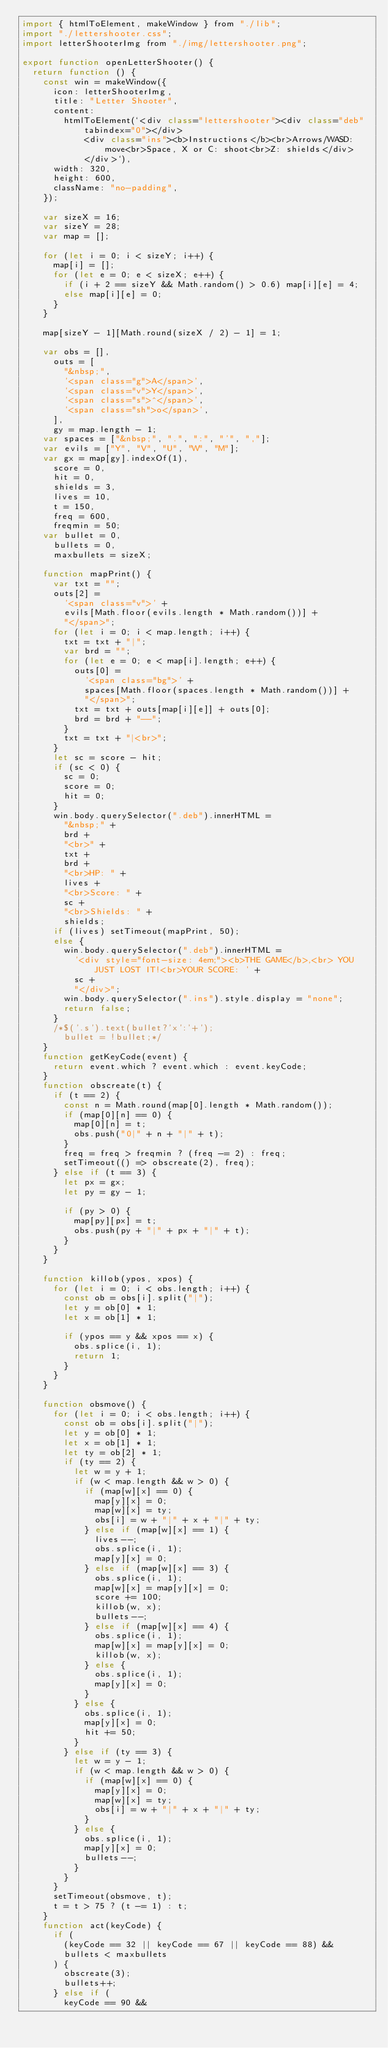<code> <loc_0><loc_0><loc_500><loc_500><_JavaScript_>import { htmlToElement, makeWindow } from "./lib";
import "./lettershooter.css";
import letterShooterImg from "./img/lettershooter.png";

export function openLetterShooter() {
  return function () {
    const win = makeWindow({
      icon: letterShooterImg,
      title: "Letter Shooter",
      content:
        htmlToElement(`<div class="lettershooter"><div class="deb" tabindex="0"></div>
            <div class="ins"><b>Instructions</b><br>Arrows/WASD: move<br>Space, X or C: shoot<br>Z: shields</div>
            </div>`),
      width: 320,
      height: 600,
      className: "no-padding",
    });

    var sizeX = 16;
    var sizeY = 28;
    var map = [];

    for (let i = 0; i < sizeY; i++) {
      map[i] = [];
      for (let e = 0; e < sizeX; e++) {
        if (i + 2 == sizeY && Math.random() > 0.6) map[i][e] = 4;
        else map[i][e] = 0;
      }
    }

    map[sizeY - 1][Math.round(sizeX / 2) - 1] = 1;

    var obs = [],
      outs = [
        "&nbsp;",
        '<span class="g">A</span>',
        '<span class="v">Y</span>',
        '<span class="s">^</span>',
        '<span class="sh">o</span>',
      ],
      gy = map.length - 1;
    var spaces = ["&nbsp;", ".", ":", "'", ","];
    var evils = ["Y", "V", "U", "W", "M"];
    var gx = map[gy].indexOf(1),
      score = 0,
      hit = 0,
      shields = 3,
      lives = 10,
      t = 150,
      freq = 600,
      freqmin = 50;
    var bullet = 0,
      bullets = 0,
      maxbullets = sizeX;

    function mapPrint() {
      var txt = "";
      outs[2] =
        '<span class="v">' +
        evils[Math.floor(evils.length * Math.random())] +
        "</span>";
      for (let i = 0; i < map.length; i++) {
        txt = txt + "|";
        var brd = "";
        for (let e = 0; e < map[i].length; e++) {
          outs[0] =
            '<span class="bg">' +
            spaces[Math.floor(spaces.length * Math.random())] +
            "</span>";
          txt = txt + outs[map[i][e]] + outs[0];
          brd = brd + "--";
        }
        txt = txt + "|<br>";
      }
      let sc = score - hit;
      if (sc < 0) {
        sc = 0;
        score = 0;
        hit = 0;
      }
      win.body.querySelector(".deb").innerHTML =
        "&nbsp;" +
        brd +
        "<br>" +
        txt +
        brd +
        "<br>HP: " +
        lives +
        "<br>Score: " +
        sc +
        "<br>Shields: " +
        shields;
      if (lives) setTimeout(mapPrint, 50);
      else {
        win.body.querySelector(".deb").innerHTML =
          '<div style="font-size: 4em;"><b>THE GAME</b>,<br> YOU JUST LOST IT!<br>YOUR SCORE: ' +
          sc +
          "</div>";
        win.body.querySelector(".ins").style.display = "none";
        return false;
      }
      /*$('.s').text(bullet?'x':'+');
        bullet = !bullet;*/
    }
    function getKeyCode(event) {
      return event.which ? event.which : event.keyCode;
    }
    function obscreate(t) {
      if (t == 2) {
        const n = Math.round(map[0].length * Math.random());
        if (map[0][n] == 0) {
          map[0][n] = t;
          obs.push("0|" + n + "|" + t);
        }
        freq = freq > freqmin ? (freq -= 2) : freq;
        setTimeout(() => obscreate(2), freq);
      } else if (t == 3) {
        let px = gx;
        let py = gy - 1;

        if (py > 0) {
          map[py][px] = t;
          obs.push(py + "|" + px + "|" + t);
        }
      }
    }

    function killob(ypos, xpos) {
      for (let i = 0; i < obs.length; i++) {
        const ob = obs[i].split("|");
        let y = ob[0] * 1;
        let x = ob[1] * 1;

        if (ypos == y && xpos == x) {
          obs.splice(i, 1);
          return 1;
        }
      }
    }

    function obsmove() {
      for (let i = 0; i < obs.length; i++) {
        const ob = obs[i].split("|");
        let y = ob[0] * 1;
        let x = ob[1] * 1;
        let ty = ob[2] * 1;
        if (ty == 2) {
          let w = y + 1;
          if (w < map.length && w > 0) {
            if (map[w][x] == 0) {
              map[y][x] = 0;
              map[w][x] = ty;
              obs[i] = w + "|" + x + "|" + ty;
            } else if (map[w][x] == 1) {
              lives--;
              obs.splice(i, 1);
              map[y][x] = 0;
            } else if (map[w][x] == 3) {
              obs.splice(i, 1);
              map[w][x] = map[y][x] = 0;
              score += 100;
              killob(w, x);
              bullets--;
            } else if (map[w][x] == 4) {
              obs.splice(i, 1);
              map[w][x] = map[y][x] = 0;
              killob(w, x);
            } else {
              obs.splice(i, 1);
              map[y][x] = 0;
            }
          } else {
            obs.splice(i, 1);
            map[y][x] = 0;
            hit += 50;
          }
        } else if (ty == 3) {
          let w = y - 1;
          if (w < map.length && w > 0) {
            if (map[w][x] == 0) {
              map[y][x] = 0;
              map[w][x] = ty;
              obs[i] = w + "|" + x + "|" + ty;
            }
          } else {
            obs.splice(i, 1);
            map[y][x] = 0;
            bullets--;
          }
        }
      }
      setTimeout(obsmove, t);
      t = t > 75 ? (t -= 1) : t;
    }
    function act(keyCode) {
      if (
        (keyCode == 32 || keyCode == 67 || keyCode == 88) &&
        bullets < maxbullets
      ) {
        obscreate(3);
        bullets++;
      } else if (
        keyCode == 90 &&</code> 